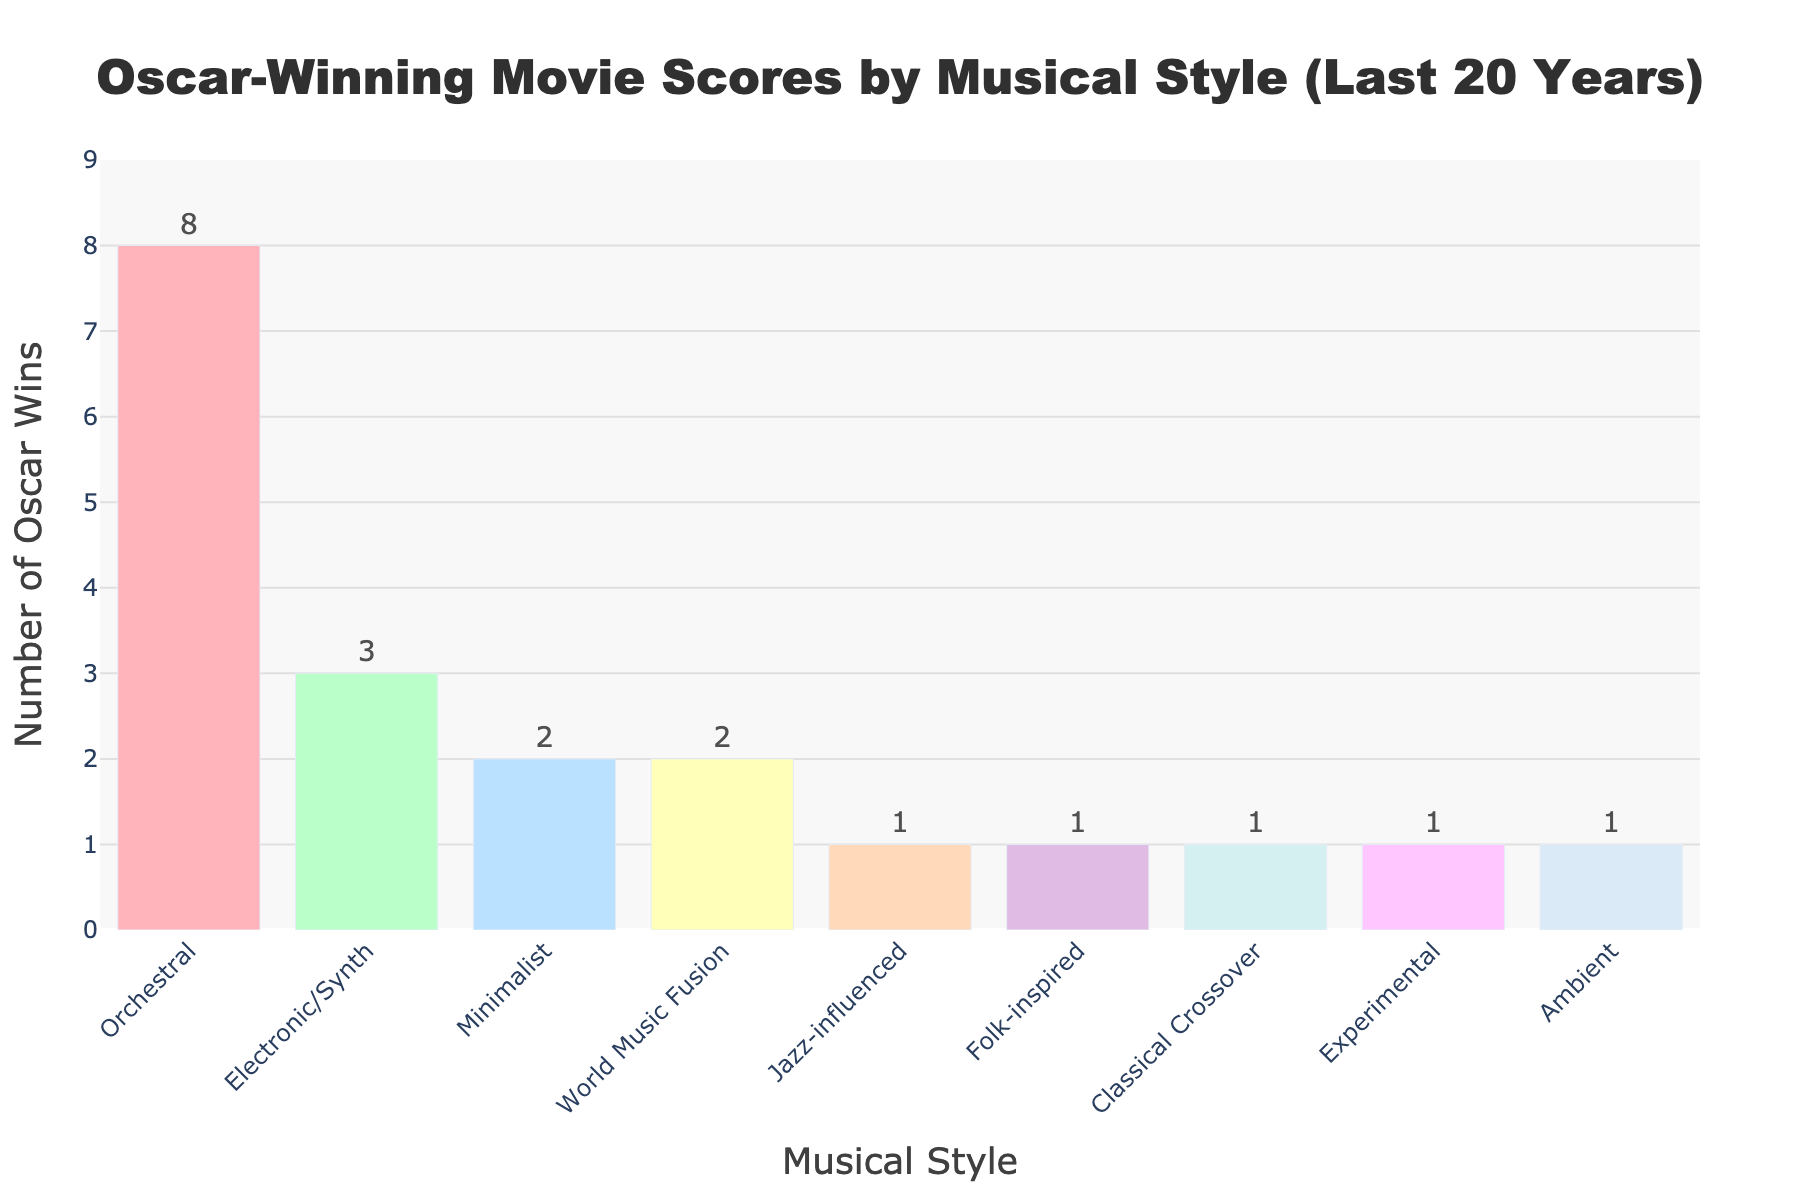What is the most commonly seen musical style in Oscar-winning movie scores over the last 20 years? The highest bar in the chart represents the most common musical style. Here, the "Orchestral" style has the tallest bar, indicating the highest number of Oscar wins.
Answer: Orchestral Which musical styles have won exactly 2 Oscars in the last 20 years? Look for bars that are at the height representing a value of 2. There are two such bars, labeled "Minimalist" and "World Music Fusion."
Answer: Minimalist, World Music Fusion How many more Oscars have orchestral scores won compared to electronic/synth scores? The bar for "Orchestral" is labeled with 8, and the bar for "Electronic/Synth" is labeled with 3. The difference is 8 - 3.
Answer: 5 Which musical styles have won only 1 Oscar? Identify the bars that are at the height representing a value of 1. The musical styles are labeled "Jazz-influenced," "Folk-inspired," "Classical Crossover," "Experimental," and "Ambient."
Answer: Jazz-influenced, Folk-inspired, Classical Crossover, Experimental, Ambient What is the total number of Oscar wins for the styles that are not orchestral? Sum up all the wins of non-orchestral styles: 3 (Electronic/Synth) + 2 (Minimalist) + 2 (World Music Fusion) + 1 (Jazz-influenced) + 1 (Folk-inspired) + 1 (Classical Crossover) + 1 (Experimental) + 1 (Ambient).
Answer: 12 How does the bar for "Jazz-influenced" compare visually to the one for "Electronic/Synth"? The bar for "Jazz-influenced" is shorter and is labeled with the number 1, whereas the bar for "Electronic/Synth" is taller and labeled with the number 3.
Answer: Shorter What is the sum of Oscar wins for the two least common musical styles? Identify the two styles with the smallest individual counts: "Jazz-influenced," "Folk-inspired," "Classical Crossover," "Experimental," and "Ambient," all with 1 win each. Sum any two of these, e.g., 1 + 1.
Answer: 2 If you were to average the number of Oscar wins across all musical styles, what would that average be? Add up the total number of wins (8 + 3 + 2 + 2 + 1 + 1 + 1 + 1 + 1 = 20) and divide by the number of styles (9). 20 / 9 = 2.22, approximately.
Answer: 2.22 Which musical styles have half the number of Oscars compared to the "Orchestral" style? "Orchestral" has 8 wins; half of that is 4. No bars are at the height of 4, so no styles meet this criterion.
Answer: None 